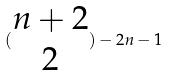<formula> <loc_0><loc_0><loc_500><loc_500>( \begin{matrix} n + 2 \\ 2 \end{matrix} ) - 2 n - 1</formula> 